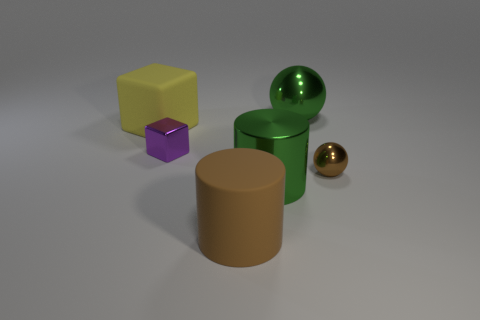Subtract 1 cubes. How many cubes are left? 1 Subtract all purple blocks. How many blocks are left? 1 Add 2 large yellow cubes. How many objects exist? 8 Subtract all balls. How many objects are left? 4 Add 1 purple blocks. How many purple blocks are left? 2 Add 2 tiny brown spheres. How many tiny brown spheres exist? 3 Subtract 0 gray cylinders. How many objects are left? 6 Subtract all cyan balls. Subtract all cyan cylinders. How many balls are left? 2 Subtract all cyan cylinders. How many gray spheres are left? 0 Subtract all big green metallic cylinders. Subtract all tiny brown balls. How many objects are left? 4 